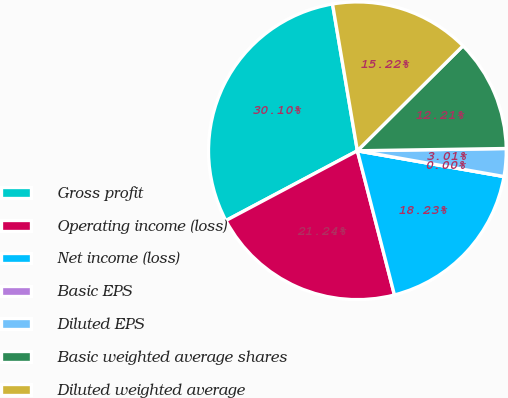<chart> <loc_0><loc_0><loc_500><loc_500><pie_chart><fcel>Gross profit<fcel>Operating income (loss)<fcel>Net income (loss)<fcel>Basic EPS<fcel>Diluted EPS<fcel>Basic weighted average shares<fcel>Diluted weighted average<nl><fcel>30.1%<fcel>21.24%<fcel>18.23%<fcel>0.0%<fcel>3.01%<fcel>12.21%<fcel>15.22%<nl></chart> 